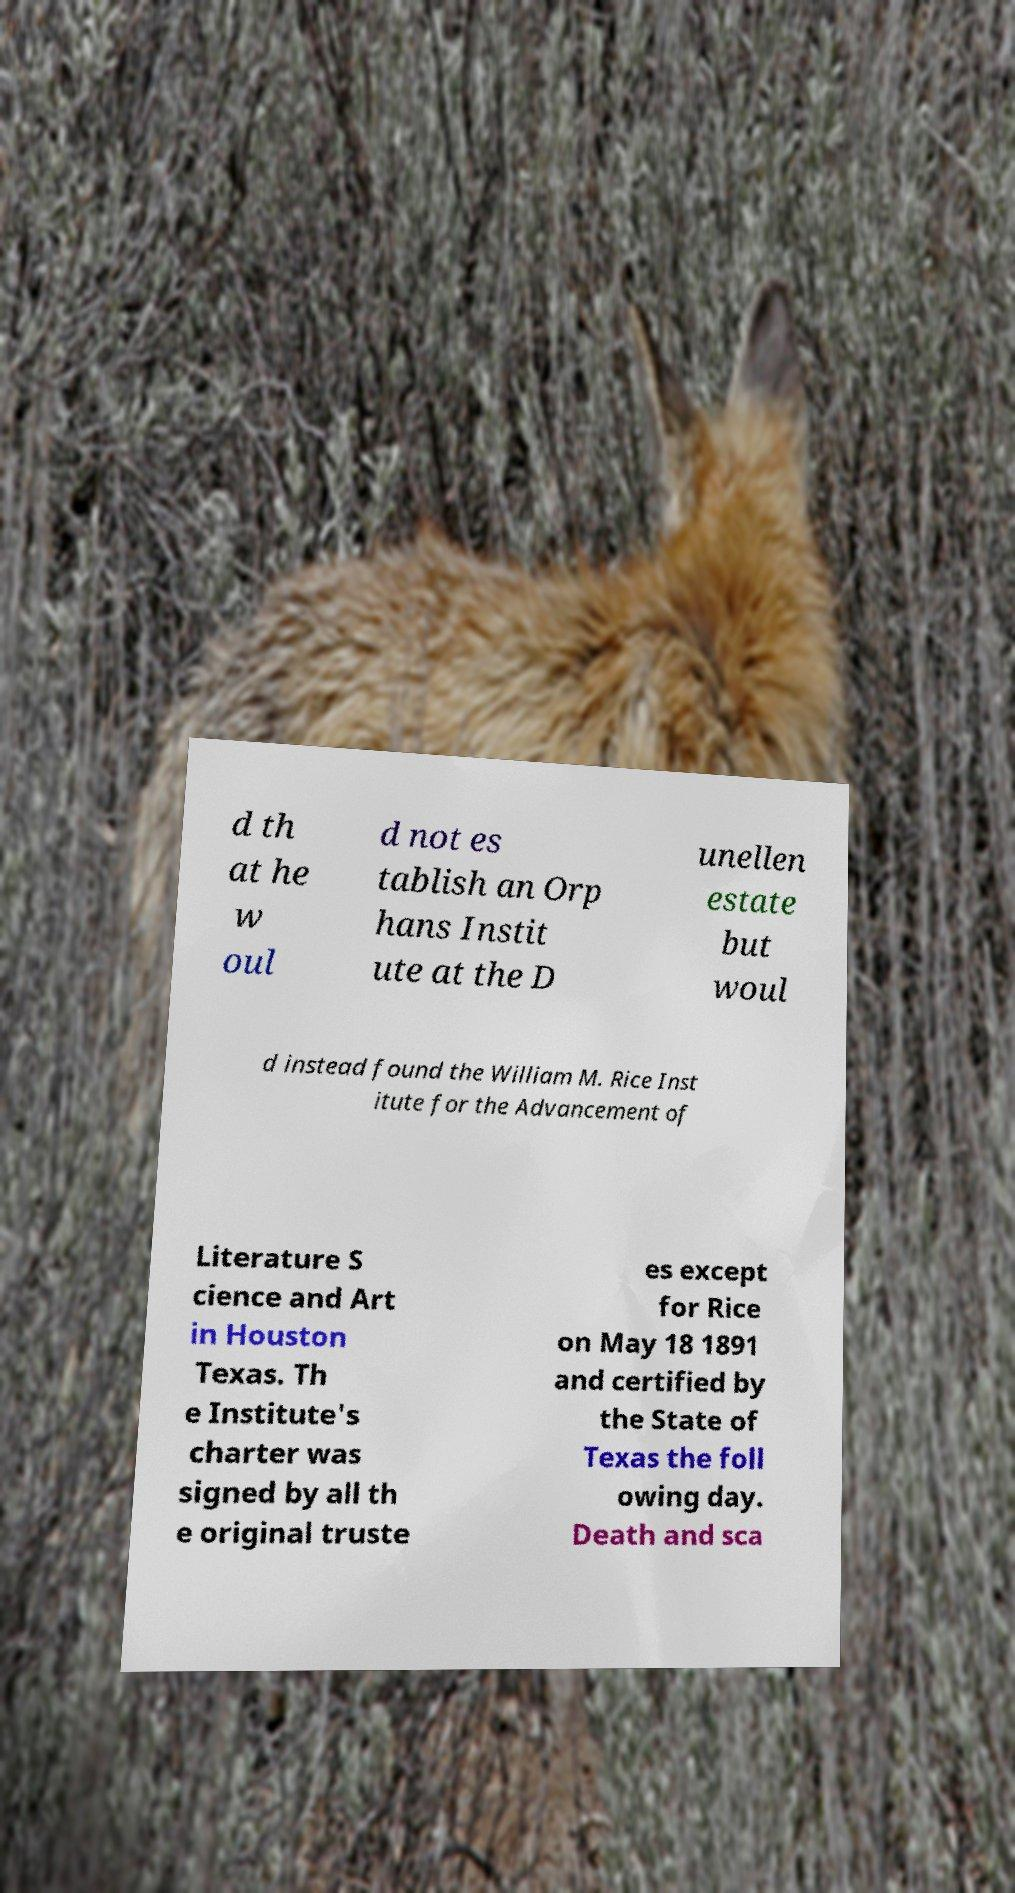Please read and relay the text visible in this image. What does it say? d th at he w oul d not es tablish an Orp hans Instit ute at the D unellen estate but woul d instead found the William M. Rice Inst itute for the Advancement of Literature S cience and Art in Houston Texas. Th e Institute's charter was signed by all th e original truste es except for Rice on May 18 1891 and certified by the State of Texas the foll owing day. Death and sca 